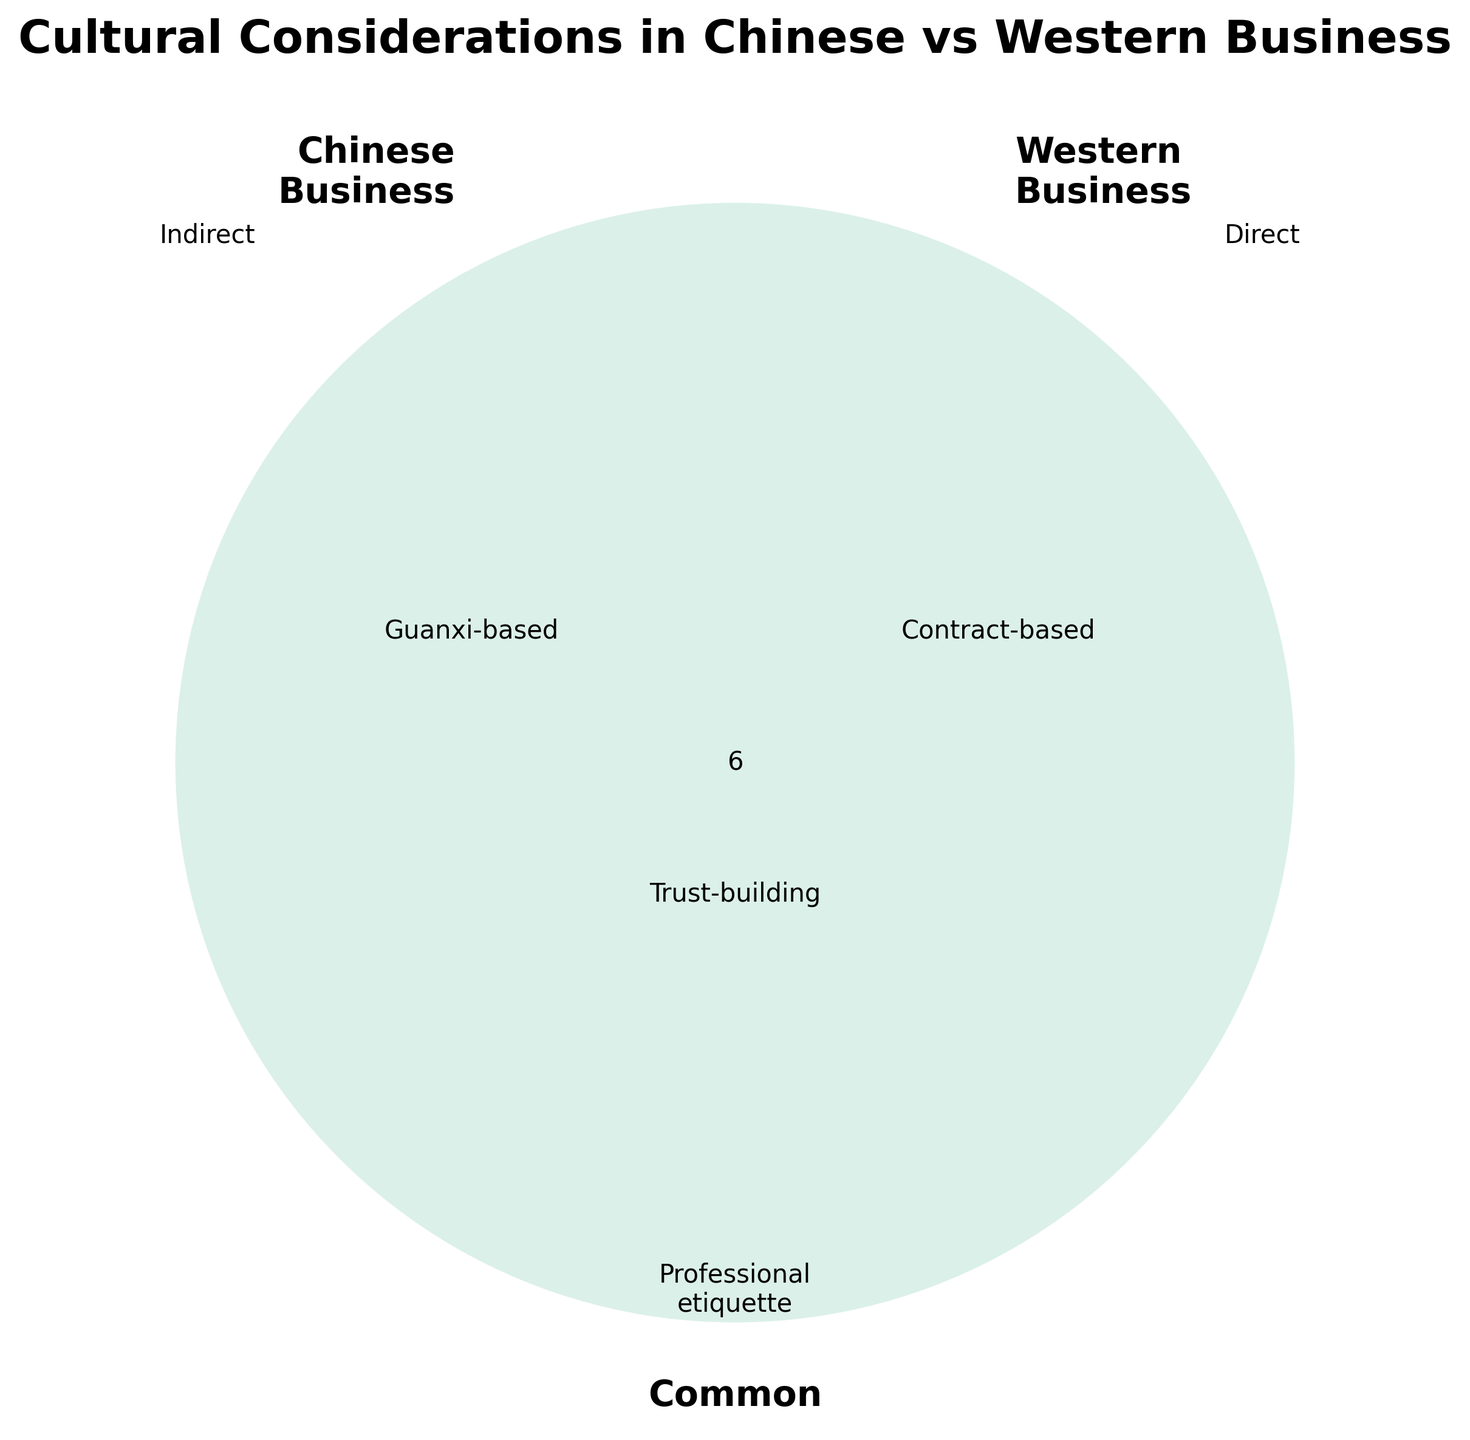what does the Venn diagram's title indicate? The title indicates that the Venn diagram compares cultural considerations in Chinese vs Western business practices.
Answer: Cultural Considerations in Chinese vs Western Business which category is labeled as "Contract-based"? The "Contract-based" category is found in the Western Business circle.
Answer: Western Business what common category involves "Professional etiquette"? The "Professional etiquette" category is a common element shared by both Chinese and Western businesses.
Answer: Professional etiquette where would you find "Guanxi-based" relationships? "Guanxi-based" relationships are located in the Chinese Business circle.
Answer: Chinese Business how are decision-making processes depicted differently? Decision-making processes are "Hierarchical" in Chinese Business and "Collaborative" in Western Business.
Answer: Hierarchical (Chinese), Collaborative (Western) which category focuses on "Trust-building"? The "Trust-building" category is common to both Chinese and Western businesses.
Answer: Trust-building compare how time perception varies between Chinese and Western businesses. In Chinese Business, time perception is "Flexible," whereas in Western Business, it is "Punctual."
Answer: Flexible (Chinese), Punctual (Western) what negotiating approach seeks harmony, and where is it found? The negotiating approach that seeks harmony is "Harmony-seeking," found in the Chinese Business circle.
Answer: Harmony-seeking (Chinese) identify the dining etiquette prevalent in Chinese Business. The dining etiquette in Chinese Business involves "Shared dishes."
Answer: Shared dishes how do negotiation approaches differ? Chinese Business focuses on "Harmony-seeking," Western Business on "Win-win focused," but both involve "Compromise."
Answer: Harmony-seeking (Chinese), Win-win focused (Western), Compromise (Common) 